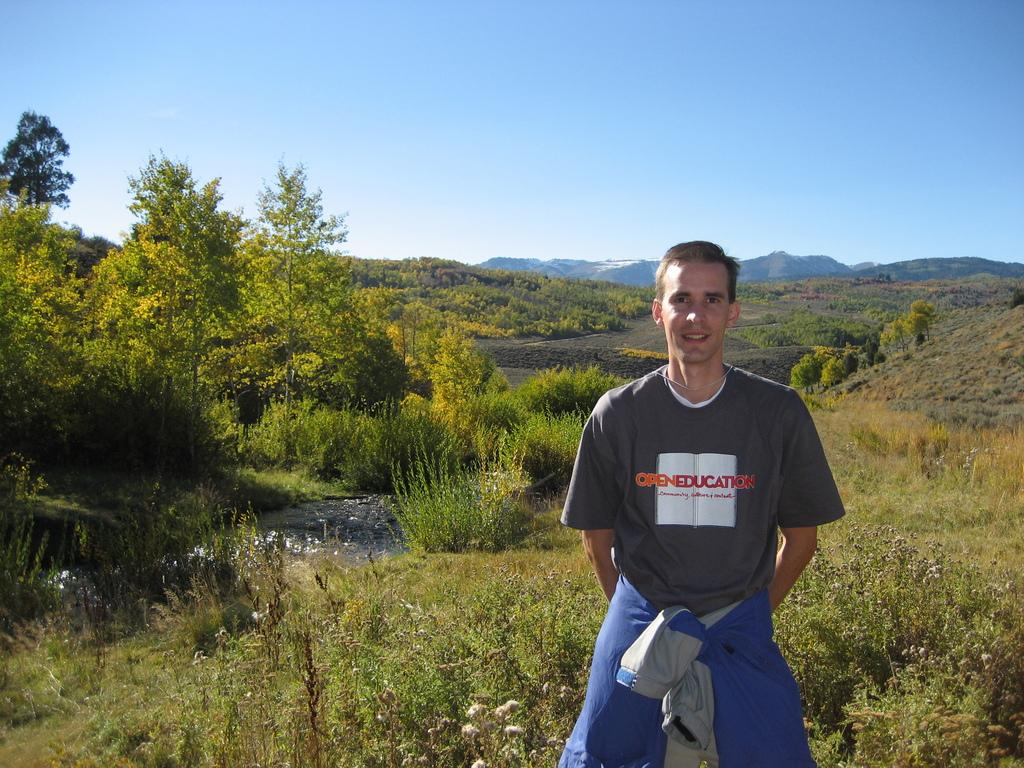What is the main subject of the image? There is a man standing in the image. What type of terrain is visible at the bottom of the image? There is grass at the bottom of the image. What can be seen in the background of the image? There are trees in the background of the image. What is visible at the top of the image? The sky is visible at the top of the image. What note is the man playing on his instrument in the image? There is no instrument or note present in the image; it only features a man standing. 